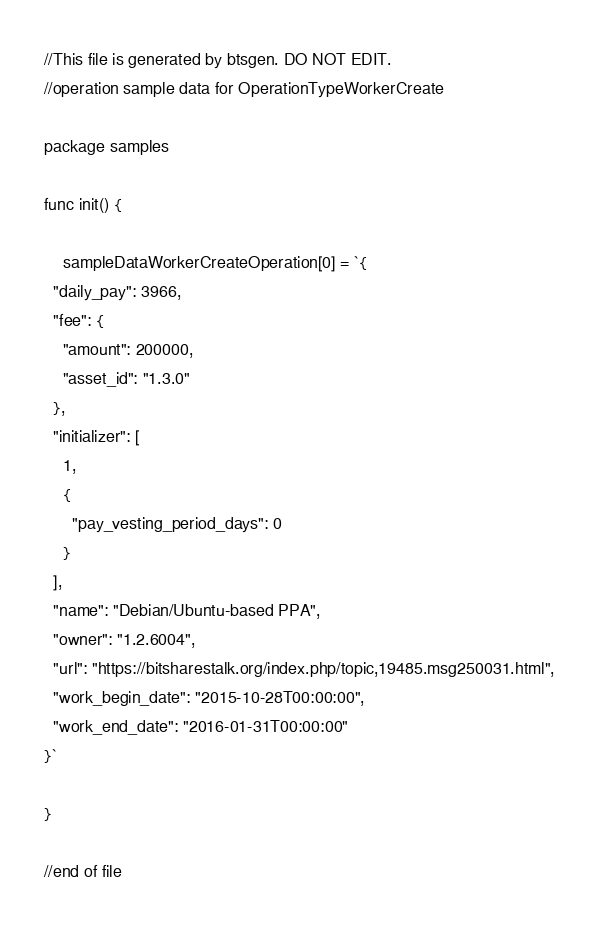<code> <loc_0><loc_0><loc_500><loc_500><_Go_>//This file is generated by btsgen. DO NOT EDIT.
//operation sample data for OperationTypeWorkerCreate

package samples

func init() {

	sampleDataWorkerCreateOperation[0] = `{
  "daily_pay": 3966,
  "fee": {
    "amount": 200000,
    "asset_id": "1.3.0"
  },
  "initializer": [
    1,
    {
      "pay_vesting_period_days": 0
    }
  ],
  "name": "Debian/Ubuntu-based PPA",
  "owner": "1.2.6004",
  "url": "https://bitsharestalk.org/index.php/topic,19485.msg250031.html",
  "work_begin_date": "2015-10-28T00:00:00",
  "work_end_date": "2016-01-31T00:00:00"
}`

}

//end of file
</code> 